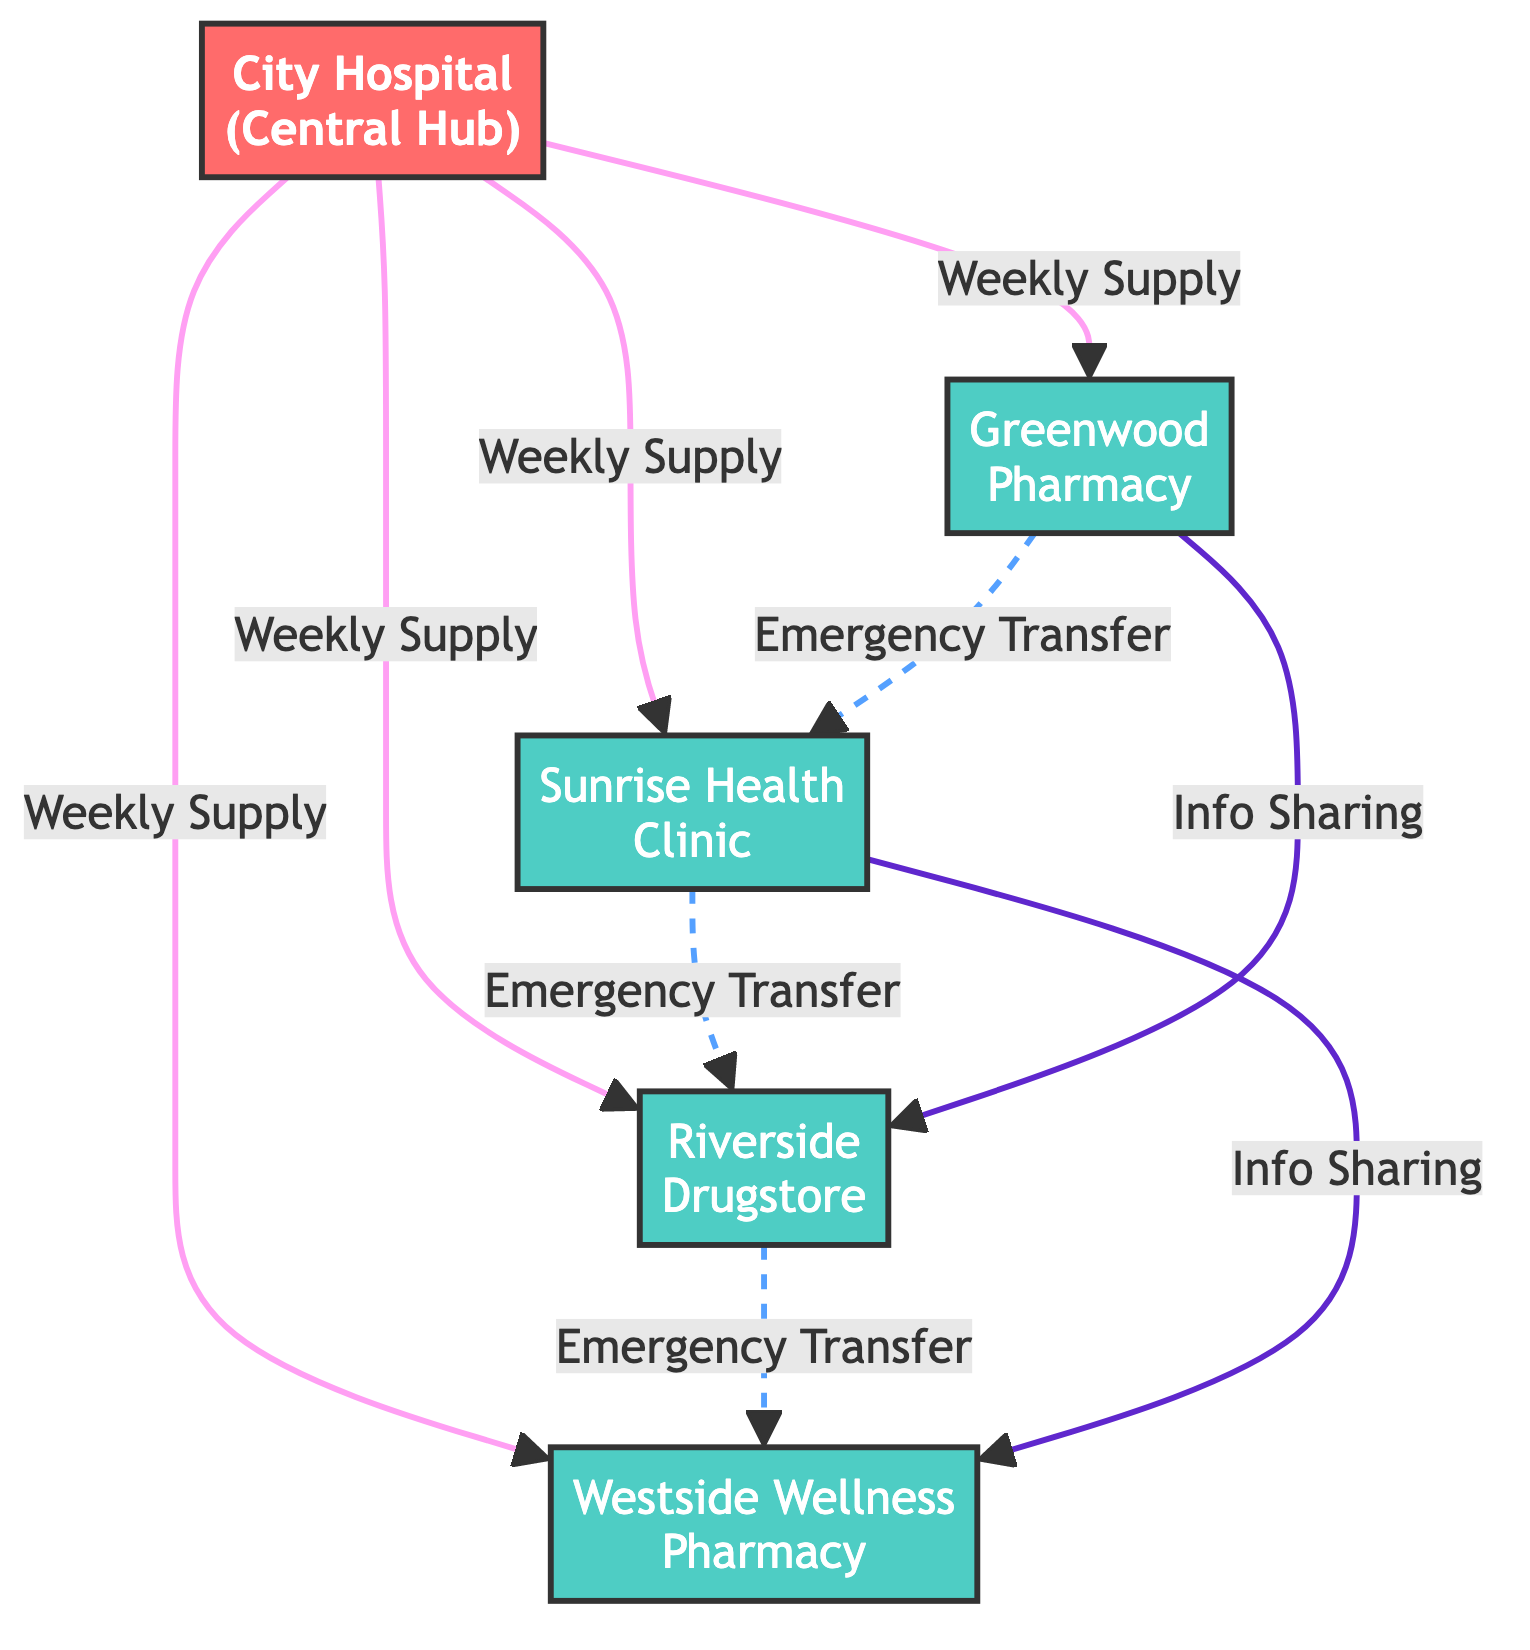What is the central distribution hub in the network? The diagram explicitly identifies the "City Hospital" as the central distribution hub, which is labeled clearly.
Answer: City Hospital How many local pharmacies are connected to the central hub? The diagram shows four local pharmacies (Greenwood Pharmacy, Sunrise Health Clinic, Riverside Drugstore, Westside Wellness Pharmacy) connected to the City Hospital.
Answer: Four What type of relationship connects the City Hospital to each local pharmacy? The relationships are labeled as "Weekly Vaccine Supply," indicating that the City Hospital supplies vaccines weekly to each local pharmacy.
Answer: Weekly Vaccine Supply Which two pharmacies share information based on the diagram? The diagram specifies that Greenwood Pharmacy and Riverside Drugstore share information, as denoted by the "Information Sharing" connection between them.
Answer: Greenwood Pharmacy and Riverside Drugstore How many emergency stock transfers are depicted in the diagram? Upon reviewing the edges related to emergency transfers, there are three connections for emergency stock transfer: from Greenwood to Sunrise, Sunrise to Riverside, and Riverside to Westside.
Answer: Three Which nodes have emergency stock transfer relationships? The diagram outlines emergency stock transfer relationships from Greenwood to Sunrise, Sunrise to Riverside, and Riverside to Westside, indicating that these are the pharmacies involved.
Answer: Greenwood, Sunrise, Riverside, Westside What type of node is "Westside Wellness Pharmacy"? The diagram classifies "Westside Wellness Pharmacy" explicitly as a "Local Pharmacy."
Answer: Local Pharmacy What does the dashed line between the nodes indicate? The dashed line represents "Emergency Stock Transfer," signaling a different type of connection compared to solid lines, which denote weekly supplies.
Answer: Emergency Stock Transfer Which pharmacies participate in information sharing? According to the edges labeled "Information Sharing," the pharmacies involved are Greenwood Pharmacy, Riverside Drugstore, Sunrise Health Clinic, and Westside Wellness Pharmacy.
Answer: Greenwood Pharmacy, Riverside Drugstore, Sunrise Health Clinic, Westside Wellness Pharmacy 